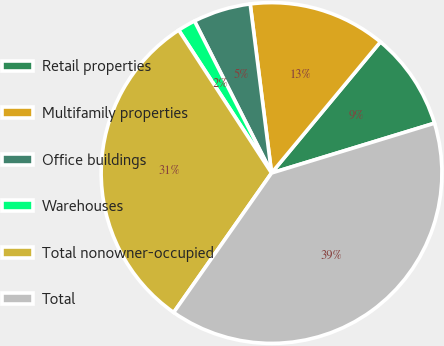Convert chart to OTSL. <chart><loc_0><loc_0><loc_500><loc_500><pie_chart><fcel>Retail properties<fcel>Multifamily properties<fcel>Office buildings<fcel>Warehouses<fcel>Total nonowner-occupied<fcel>Total<nl><fcel>9.25%<fcel>13.03%<fcel>5.47%<fcel>1.7%<fcel>31.09%<fcel>39.46%<nl></chart> 